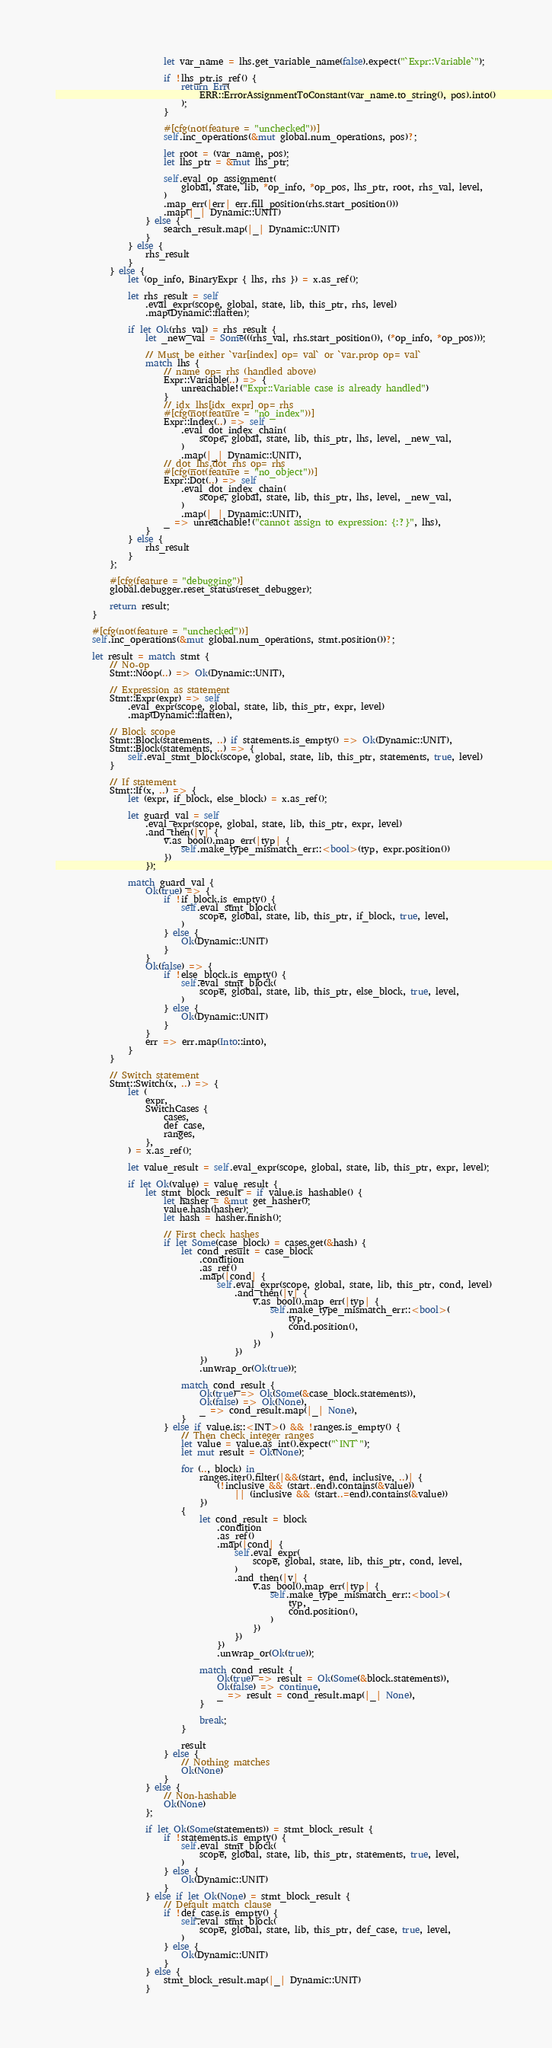Convert code to text. <code><loc_0><loc_0><loc_500><loc_500><_Rust_>                        let var_name = lhs.get_variable_name(false).expect("`Expr::Variable`");

                        if !lhs_ptr.is_ref() {
                            return Err(
                                ERR::ErrorAssignmentToConstant(var_name.to_string(), pos).into()
                            );
                        }

                        #[cfg(not(feature = "unchecked"))]
                        self.inc_operations(&mut global.num_operations, pos)?;

                        let root = (var_name, pos);
                        let lhs_ptr = &mut lhs_ptr;

                        self.eval_op_assignment(
                            global, state, lib, *op_info, *op_pos, lhs_ptr, root, rhs_val, level,
                        )
                        .map_err(|err| err.fill_position(rhs.start_position()))
                        .map(|_| Dynamic::UNIT)
                    } else {
                        search_result.map(|_| Dynamic::UNIT)
                    }
                } else {
                    rhs_result
                }
            } else {
                let (op_info, BinaryExpr { lhs, rhs }) = x.as_ref();

                let rhs_result = self
                    .eval_expr(scope, global, state, lib, this_ptr, rhs, level)
                    .map(Dynamic::flatten);

                if let Ok(rhs_val) = rhs_result {
                    let _new_val = Some(((rhs_val, rhs.start_position()), (*op_info, *op_pos)));

                    // Must be either `var[index] op= val` or `var.prop op= val`
                    match lhs {
                        // name op= rhs (handled above)
                        Expr::Variable(..) => {
                            unreachable!("Expr::Variable case is already handled")
                        }
                        // idx_lhs[idx_expr] op= rhs
                        #[cfg(not(feature = "no_index"))]
                        Expr::Index(..) => self
                            .eval_dot_index_chain(
                                scope, global, state, lib, this_ptr, lhs, level, _new_val,
                            )
                            .map(|_| Dynamic::UNIT),
                        // dot_lhs.dot_rhs op= rhs
                        #[cfg(not(feature = "no_object"))]
                        Expr::Dot(..) => self
                            .eval_dot_index_chain(
                                scope, global, state, lib, this_ptr, lhs, level, _new_val,
                            )
                            .map(|_| Dynamic::UNIT),
                        _ => unreachable!("cannot assign to expression: {:?}", lhs),
                    }
                } else {
                    rhs_result
                }
            };

            #[cfg(feature = "debugging")]
            global.debugger.reset_status(reset_debugger);

            return result;
        }

        #[cfg(not(feature = "unchecked"))]
        self.inc_operations(&mut global.num_operations, stmt.position())?;

        let result = match stmt {
            // No-op
            Stmt::Noop(..) => Ok(Dynamic::UNIT),

            // Expression as statement
            Stmt::Expr(expr) => self
                .eval_expr(scope, global, state, lib, this_ptr, expr, level)
                .map(Dynamic::flatten),

            // Block scope
            Stmt::Block(statements, ..) if statements.is_empty() => Ok(Dynamic::UNIT),
            Stmt::Block(statements, ..) => {
                self.eval_stmt_block(scope, global, state, lib, this_ptr, statements, true, level)
            }

            // If statement
            Stmt::If(x, ..) => {
                let (expr, if_block, else_block) = x.as_ref();

                let guard_val = self
                    .eval_expr(scope, global, state, lib, this_ptr, expr, level)
                    .and_then(|v| {
                        v.as_bool().map_err(|typ| {
                            self.make_type_mismatch_err::<bool>(typ, expr.position())
                        })
                    });

                match guard_val {
                    Ok(true) => {
                        if !if_block.is_empty() {
                            self.eval_stmt_block(
                                scope, global, state, lib, this_ptr, if_block, true, level,
                            )
                        } else {
                            Ok(Dynamic::UNIT)
                        }
                    }
                    Ok(false) => {
                        if !else_block.is_empty() {
                            self.eval_stmt_block(
                                scope, global, state, lib, this_ptr, else_block, true, level,
                            )
                        } else {
                            Ok(Dynamic::UNIT)
                        }
                    }
                    err => err.map(Into::into),
                }
            }

            // Switch statement
            Stmt::Switch(x, ..) => {
                let (
                    expr,
                    SwitchCases {
                        cases,
                        def_case,
                        ranges,
                    },
                ) = x.as_ref();

                let value_result = self.eval_expr(scope, global, state, lib, this_ptr, expr, level);

                if let Ok(value) = value_result {
                    let stmt_block_result = if value.is_hashable() {
                        let hasher = &mut get_hasher();
                        value.hash(hasher);
                        let hash = hasher.finish();

                        // First check hashes
                        if let Some(case_block) = cases.get(&hash) {
                            let cond_result = case_block
                                .condition
                                .as_ref()
                                .map(|cond| {
                                    self.eval_expr(scope, global, state, lib, this_ptr, cond, level)
                                        .and_then(|v| {
                                            v.as_bool().map_err(|typ| {
                                                self.make_type_mismatch_err::<bool>(
                                                    typ,
                                                    cond.position(),
                                                )
                                            })
                                        })
                                })
                                .unwrap_or(Ok(true));

                            match cond_result {
                                Ok(true) => Ok(Some(&case_block.statements)),
                                Ok(false) => Ok(None),
                                _ => cond_result.map(|_| None),
                            }
                        } else if value.is::<INT>() && !ranges.is_empty() {
                            // Then check integer ranges
                            let value = value.as_int().expect("`INT`");
                            let mut result = Ok(None);

                            for (.., block) in
                                ranges.iter().filter(|&&(start, end, inclusive, ..)| {
                                    (!inclusive && (start..end).contains(&value))
                                        || (inclusive && (start..=end).contains(&value))
                                })
                            {
                                let cond_result = block
                                    .condition
                                    .as_ref()
                                    .map(|cond| {
                                        self.eval_expr(
                                            scope, global, state, lib, this_ptr, cond, level,
                                        )
                                        .and_then(|v| {
                                            v.as_bool().map_err(|typ| {
                                                self.make_type_mismatch_err::<bool>(
                                                    typ,
                                                    cond.position(),
                                                )
                                            })
                                        })
                                    })
                                    .unwrap_or(Ok(true));

                                match cond_result {
                                    Ok(true) => result = Ok(Some(&block.statements)),
                                    Ok(false) => continue,
                                    _ => result = cond_result.map(|_| None),
                                }

                                break;
                            }

                            result
                        } else {
                            // Nothing matches
                            Ok(None)
                        }
                    } else {
                        // Non-hashable
                        Ok(None)
                    };

                    if let Ok(Some(statements)) = stmt_block_result {
                        if !statements.is_empty() {
                            self.eval_stmt_block(
                                scope, global, state, lib, this_ptr, statements, true, level,
                            )
                        } else {
                            Ok(Dynamic::UNIT)
                        }
                    } else if let Ok(None) = stmt_block_result {
                        // Default match clause
                        if !def_case.is_empty() {
                            self.eval_stmt_block(
                                scope, global, state, lib, this_ptr, def_case, true, level,
                            )
                        } else {
                            Ok(Dynamic::UNIT)
                        }
                    } else {
                        stmt_block_result.map(|_| Dynamic::UNIT)
                    }</code> 